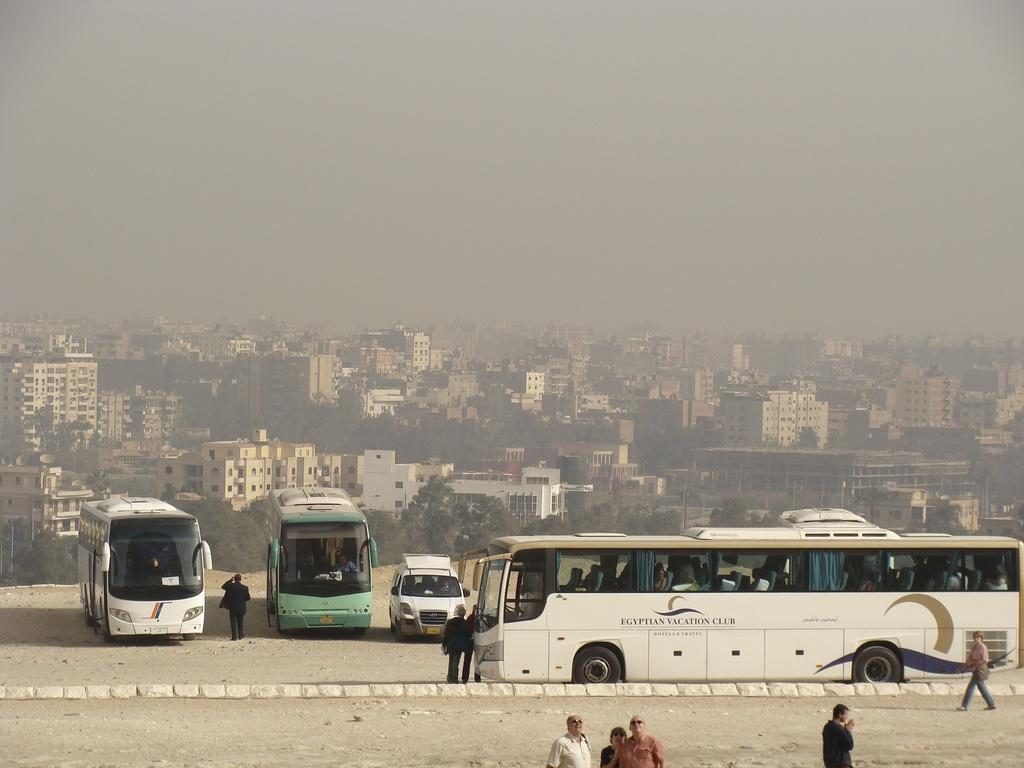Could you give a brief overview of what you see in this image? In this image there is the sky, there are buildings, there are trees, there are vehicles on the surface, there are persons, there are person truncated towards the bottom of the image, there are buildings truncated towards the left of the image, there is a tree truncated towards left of the image, there are buildings truncated towards the right of the image, there are trees truncated towards the right of the image. 